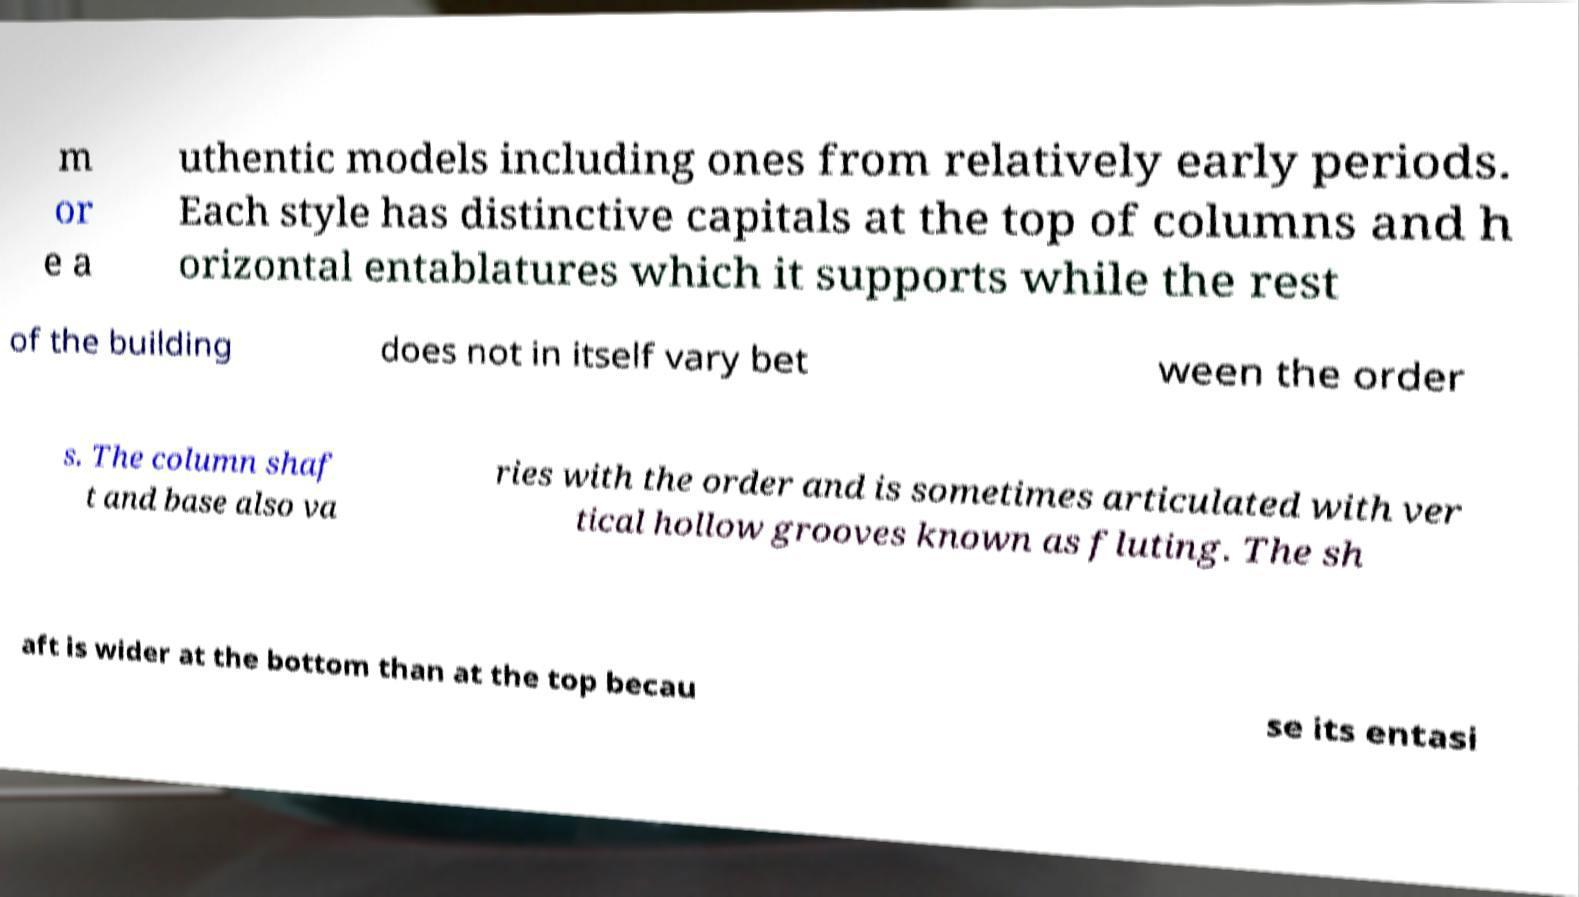I need the written content from this picture converted into text. Can you do that? m or e a uthentic models including ones from relatively early periods. Each style has distinctive capitals at the top of columns and h orizontal entablatures which it supports while the rest of the building does not in itself vary bet ween the order s. The column shaf t and base also va ries with the order and is sometimes articulated with ver tical hollow grooves known as fluting. The sh aft is wider at the bottom than at the top becau se its entasi 